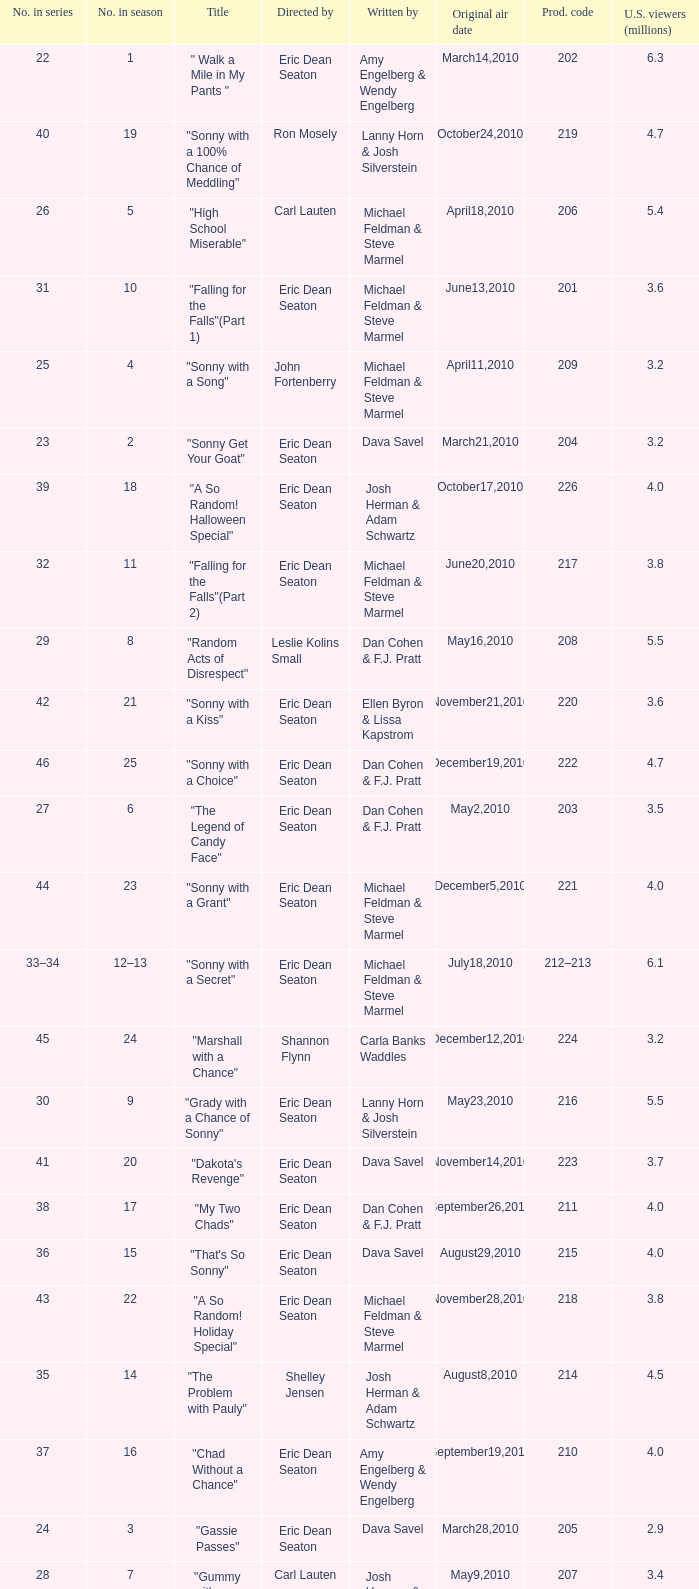Who directed the episode that 6.3 million u.s. viewers saw? Eric Dean Seaton. 